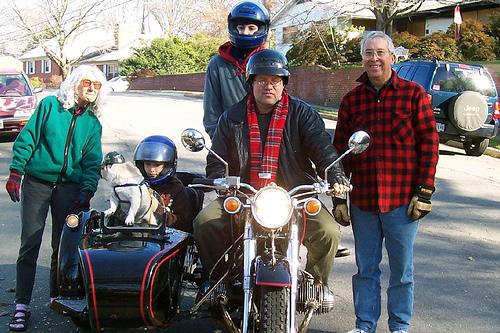Is the dog safe?
Short answer required. Yes. What is attached to the motorcycle?
Keep it brief. Sidecar. Are these bikers in a gang?
Concise answer only. No. 